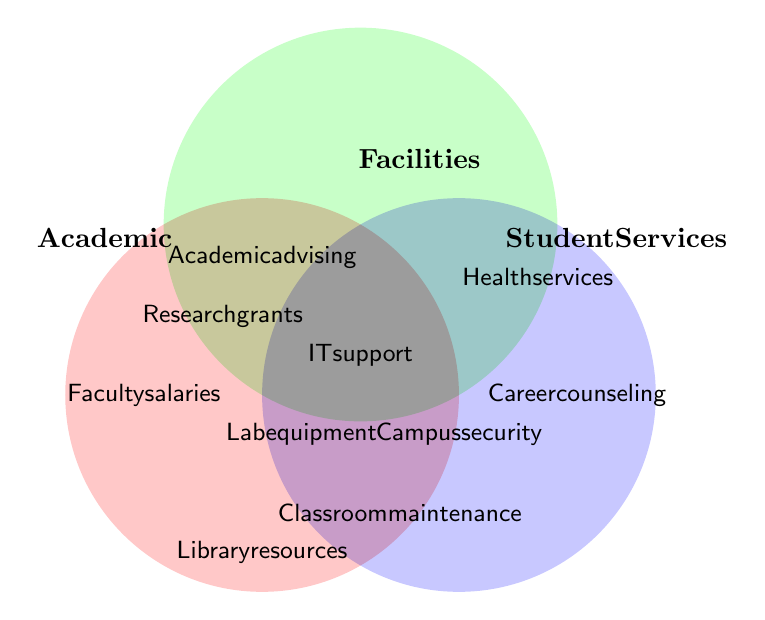Which category is represented by the red circle? The red circle overlaps with items like "Faculty salaries" and "Research grants", which belong to the Academic category.
Answer: Academic What does the intersection of the Academic and Facilities categories represent? The intersection of the Academic and Facilities categories contains items like "Lab equipment", which is relevant for both improving the academic experience and the physical facilities.
Answer: Lab equipment Which items fall under all three categories: Academic, Facilities, and Student Services? The items in the central area where all three circles overlap indicate IT support, as it serves academic purposes (e.g., online resources), facilities (e.g., maintaining tech infrastructure), and student services (e.g., online counseling platforms).
Answer: IT support How many items fall exclusively under the Academic category? The items exclusively within the Academic circle are "Faculty salaries", "Research grants", and "Library resources", making a total of three items.
Answer: Three What is the item that is common to both Facilities and Student Services but not Academic? The item in the overlapping area of Facilities and Student Services but not within the Academic circle is "Campus security", as it involves maintaining physical security, which benefits students directly.
Answer: Campus security Which categories include "Academic advising"? "Academic advising" is located in the overlapping section between Academic and Student Services, as it involves both providing academic guidance and support services to students.
Answer: Academic and Student Services Which items fall under only the Student Services category? The items located exclusively in the Student Services circle are "Health services" and "Career counseling", indicating these services are dedicated solely to student welfare.
Answer: Health services and Career counseling What color represents the Facilities category? The circle representing the Facilities category is shaded green, indicating items like "Classroom maintenance" and "Laboratory upgrades" fall under this category.
Answer: Green How many items are there in total within the Facilities category (including intersections)? Counting all items within the Facilities category including intersections with other categories, we get "Classroom maintenance", "Laboratory upgrades", "Technology infrastructure", "Lab equipment", "Campus security", and "IT support", totaling to six items.
Answer: Six What is indicated by the blue circle in the diagram? The blue circle represents the Student Services category, including items like "Career counseling", "Health services", and overlaps with other categories.
Answer: Student Services 